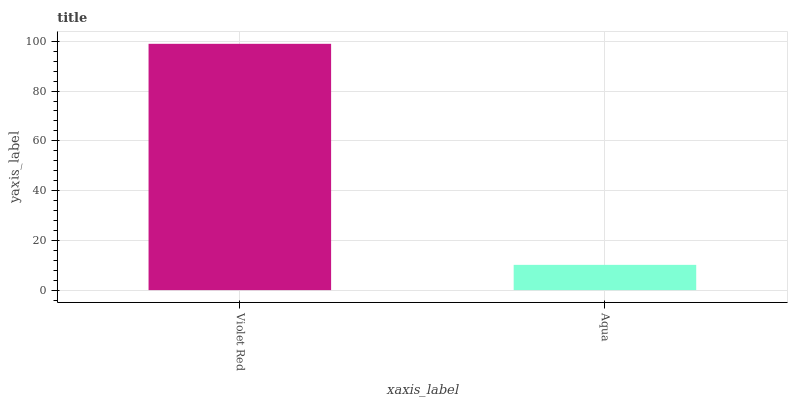Is Aqua the maximum?
Answer yes or no. No. Is Violet Red greater than Aqua?
Answer yes or no. Yes. Is Aqua less than Violet Red?
Answer yes or no. Yes. Is Aqua greater than Violet Red?
Answer yes or no. No. Is Violet Red less than Aqua?
Answer yes or no. No. Is Violet Red the high median?
Answer yes or no. Yes. Is Aqua the low median?
Answer yes or no. Yes. Is Aqua the high median?
Answer yes or no. No. Is Violet Red the low median?
Answer yes or no. No. 